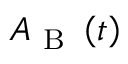Convert formula to latex. <formula><loc_0><loc_0><loc_500><loc_500>A _ { B } \left ( t \right )</formula> 